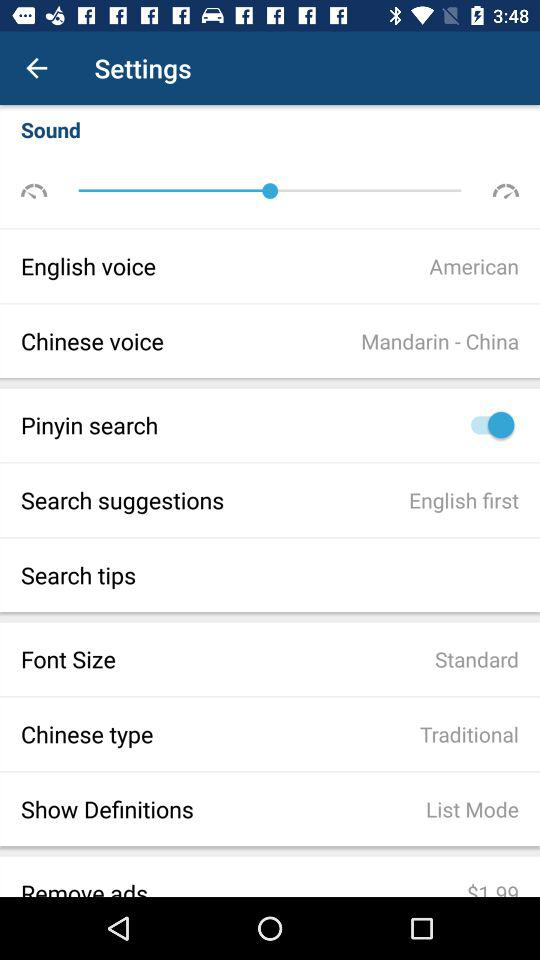How many voice options are available in the settings menu?
Answer the question using a single word or phrase. 2 